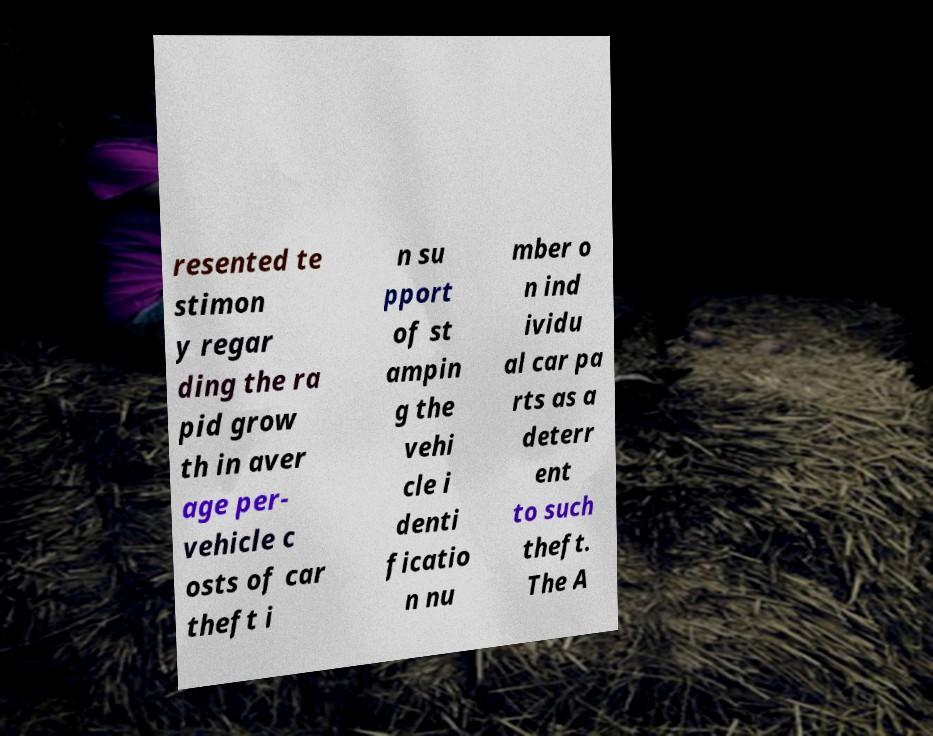Can you read and provide the text displayed in the image?This photo seems to have some interesting text. Can you extract and type it out for me? resented te stimon y regar ding the ra pid grow th in aver age per- vehicle c osts of car theft i n su pport of st ampin g the vehi cle i denti ficatio n nu mber o n ind ividu al car pa rts as a deterr ent to such theft. The A 